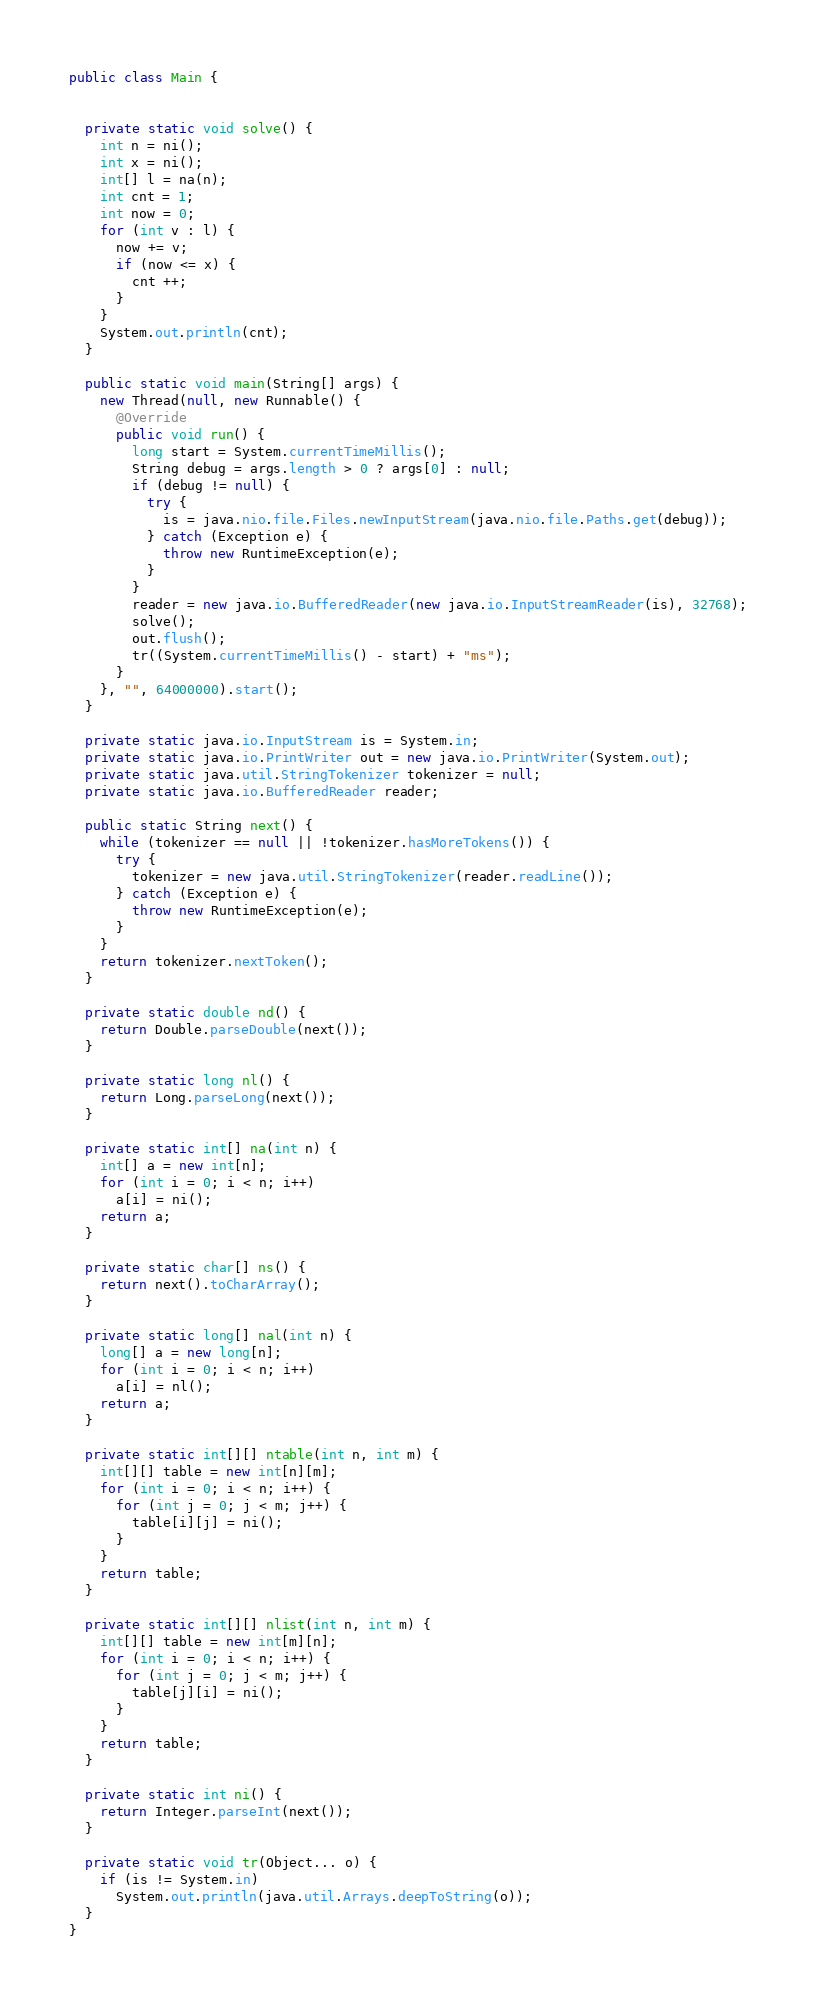Convert code to text. <code><loc_0><loc_0><loc_500><loc_500><_Java_>
public class Main {


  private static void solve() {
    int n = ni();
    int x = ni();
    int[] l = na(n);
    int cnt = 1;
    int now = 0;
    for (int v : l) {
      now += v;
      if (now <= x) {
        cnt ++;
      }
    }
    System.out.println(cnt);
  }

  public static void main(String[] args) {
    new Thread(null, new Runnable() {
      @Override
      public void run() {
        long start = System.currentTimeMillis();
        String debug = args.length > 0 ? args[0] : null;
        if (debug != null) {
          try {
            is = java.nio.file.Files.newInputStream(java.nio.file.Paths.get(debug));
          } catch (Exception e) {
            throw new RuntimeException(e);
          }
        }
        reader = new java.io.BufferedReader(new java.io.InputStreamReader(is), 32768);
        solve();
        out.flush();
        tr((System.currentTimeMillis() - start) + "ms");
      }
    }, "", 64000000).start();
  }

  private static java.io.InputStream is = System.in;
  private static java.io.PrintWriter out = new java.io.PrintWriter(System.out);
  private static java.util.StringTokenizer tokenizer = null;
  private static java.io.BufferedReader reader;

  public static String next() {
    while (tokenizer == null || !tokenizer.hasMoreTokens()) {
      try {
        tokenizer = new java.util.StringTokenizer(reader.readLine());
      } catch (Exception e) {
        throw new RuntimeException(e);
      }
    }
    return tokenizer.nextToken();
  }

  private static double nd() {
    return Double.parseDouble(next());
  }

  private static long nl() {
    return Long.parseLong(next());
  }

  private static int[] na(int n) {
    int[] a = new int[n];
    for (int i = 0; i < n; i++)
      a[i] = ni();
    return a;
  }

  private static char[] ns() {
    return next().toCharArray();
  }

  private static long[] nal(int n) {
    long[] a = new long[n];
    for (int i = 0; i < n; i++)
      a[i] = nl();
    return a;
  }

  private static int[][] ntable(int n, int m) {
    int[][] table = new int[n][m];
    for (int i = 0; i < n; i++) {
      for (int j = 0; j < m; j++) {
        table[i][j] = ni();
      }
    }
    return table;
  }

  private static int[][] nlist(int n, int m) {
    int[][] table = new int[m][n];
    for (int i = 0; i < n; i++) {
      for (int j = 0; j < m; j++) {
        table[j][i] = ni();
      }
    }
    return table;
  }

  private static int ni() {
    return Integer.parseInt(next());
  }

  private static void tr(Object... o) {
    if (is != System.in)
      System.out.println(java.util.Arrays.deepToString(o));
  }
}
</code> 